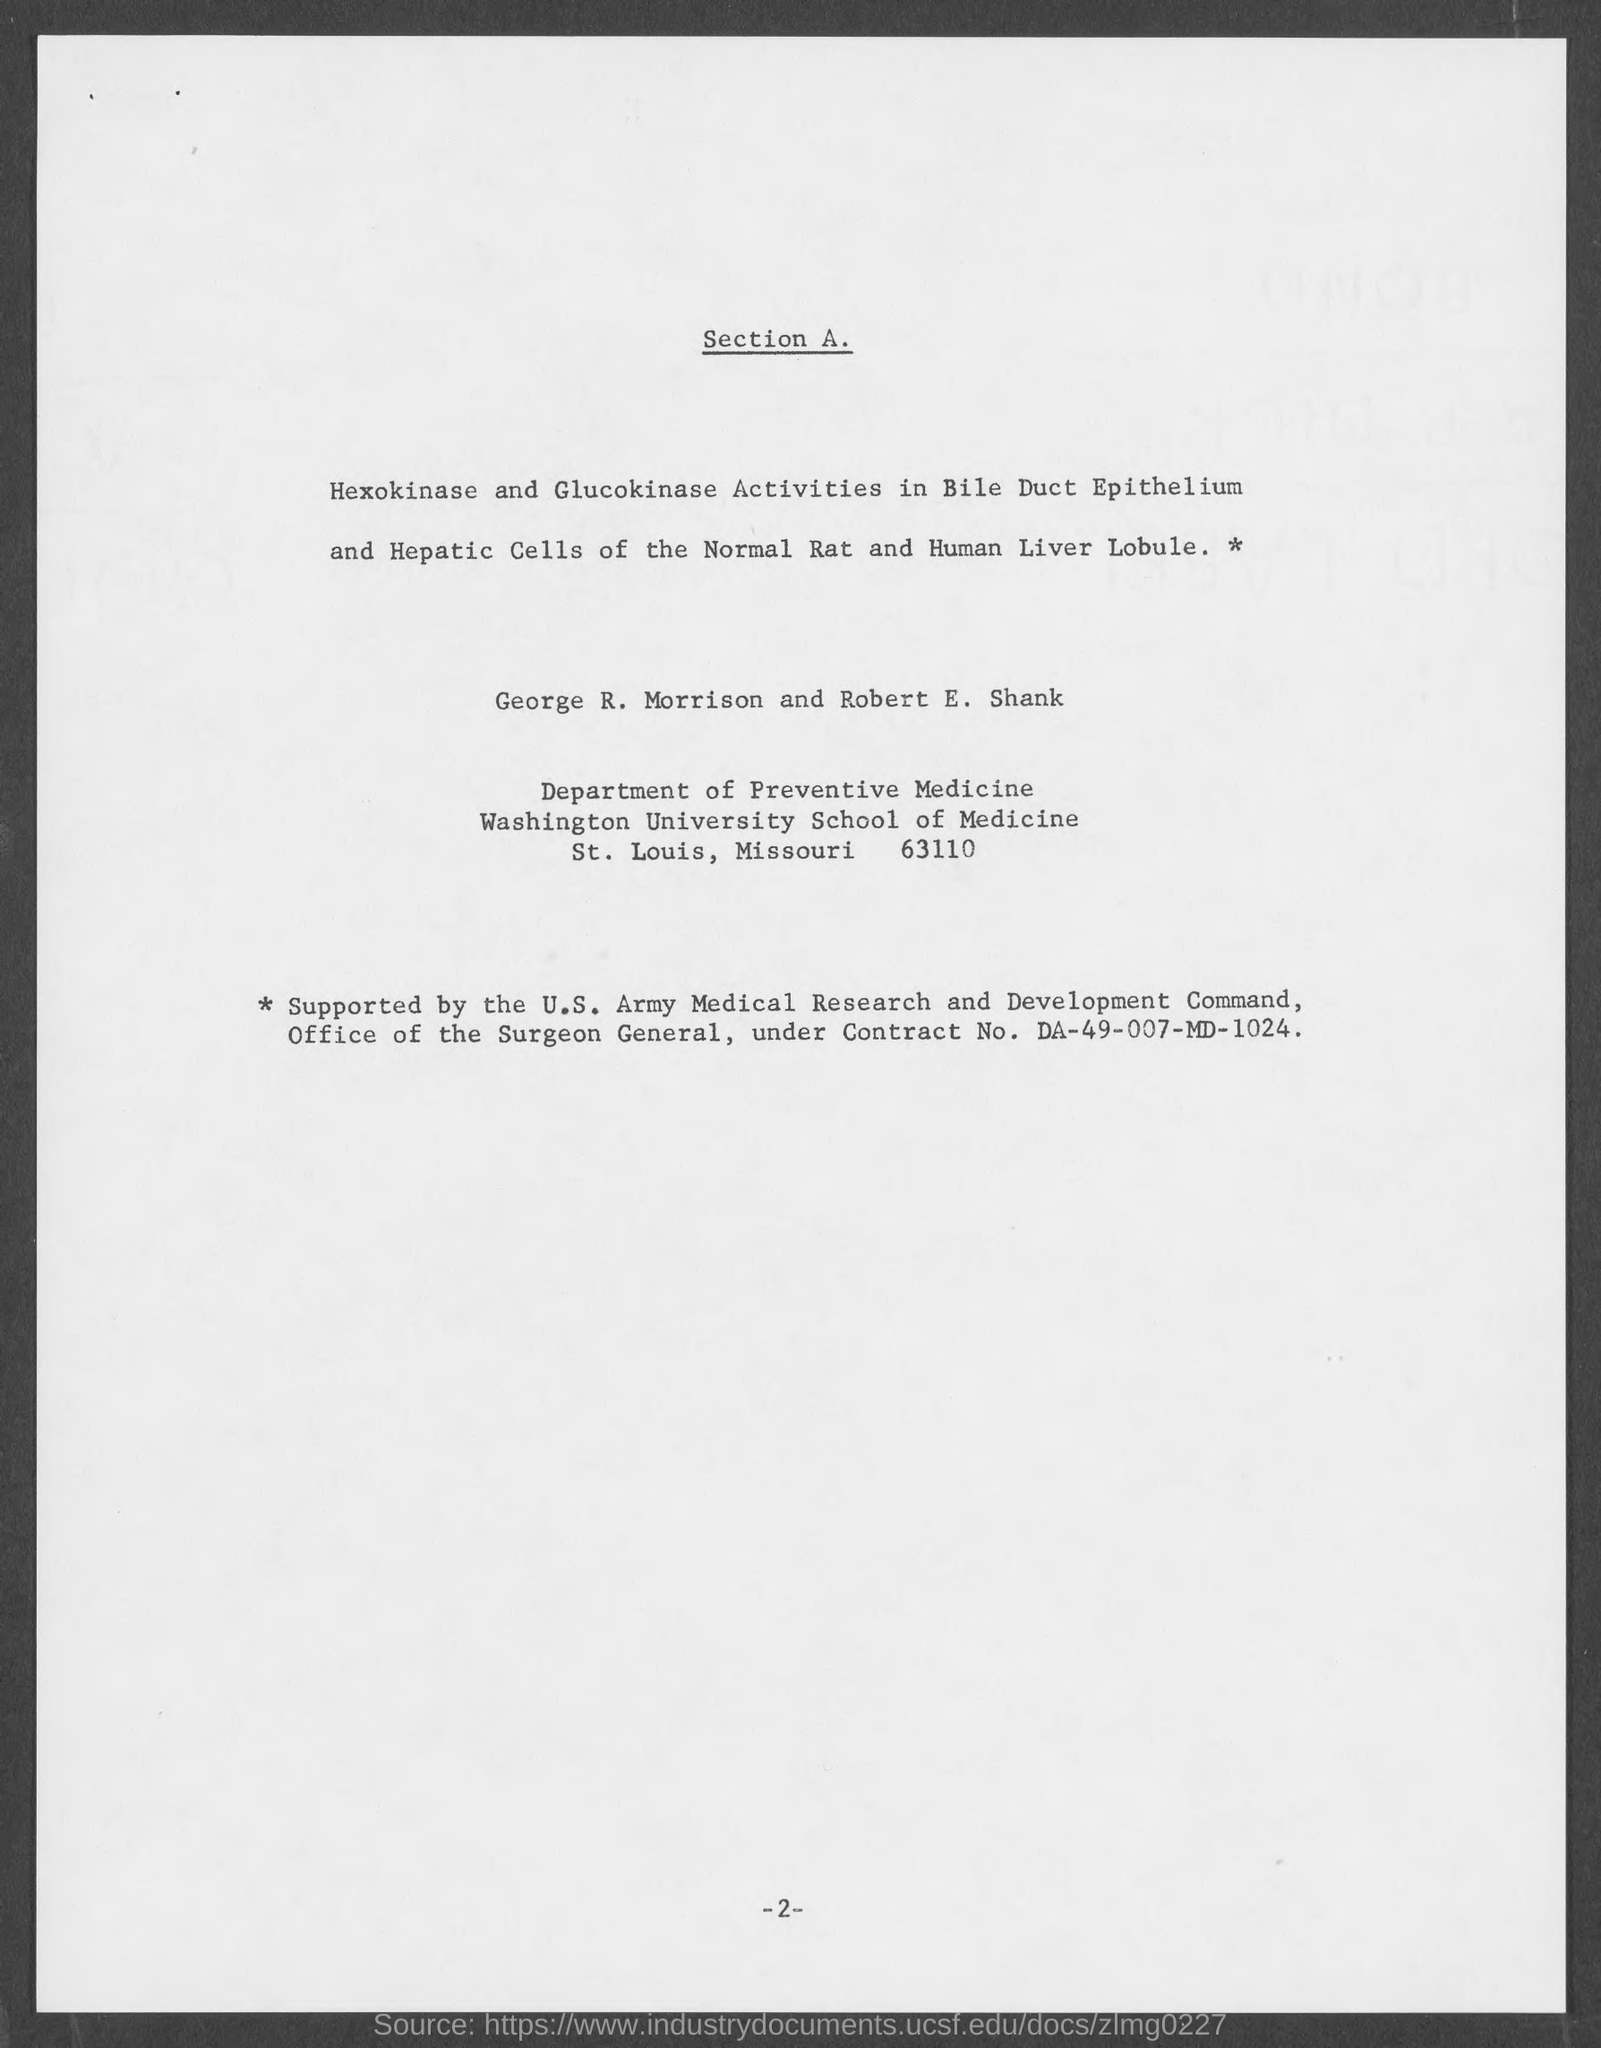What is the Contract No. given in the document?
Provide a succinct answer. DA-49-007-MD-1024. What is the page no mentioned in this document?
Your answer should be very brief. -2-. In which department, George R. Morrison and Robert E. Shank works?
Keep it short and to the point. Department of preventive medicine. 